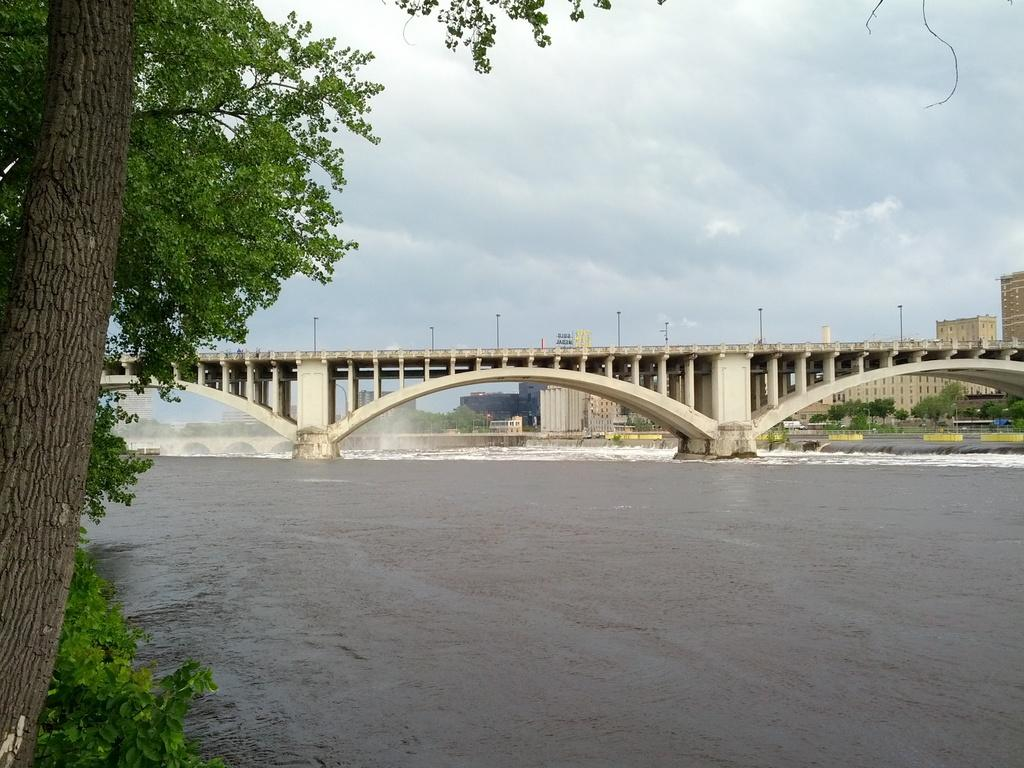What can be seen in the background of the image? There are buildings and trees in the background of the image. What architectural feature is visible in the image? There is a bridge visible in the image. What is present at the bottom portion of the image? There is water visible at the bottom portion of the image. Where are the trees located in the image? There are trees on the left side of the image. What type of cloud can be seen in the image? There is no cloud present in the image. What is the fork used for in the image? There is no fork present in the image. 